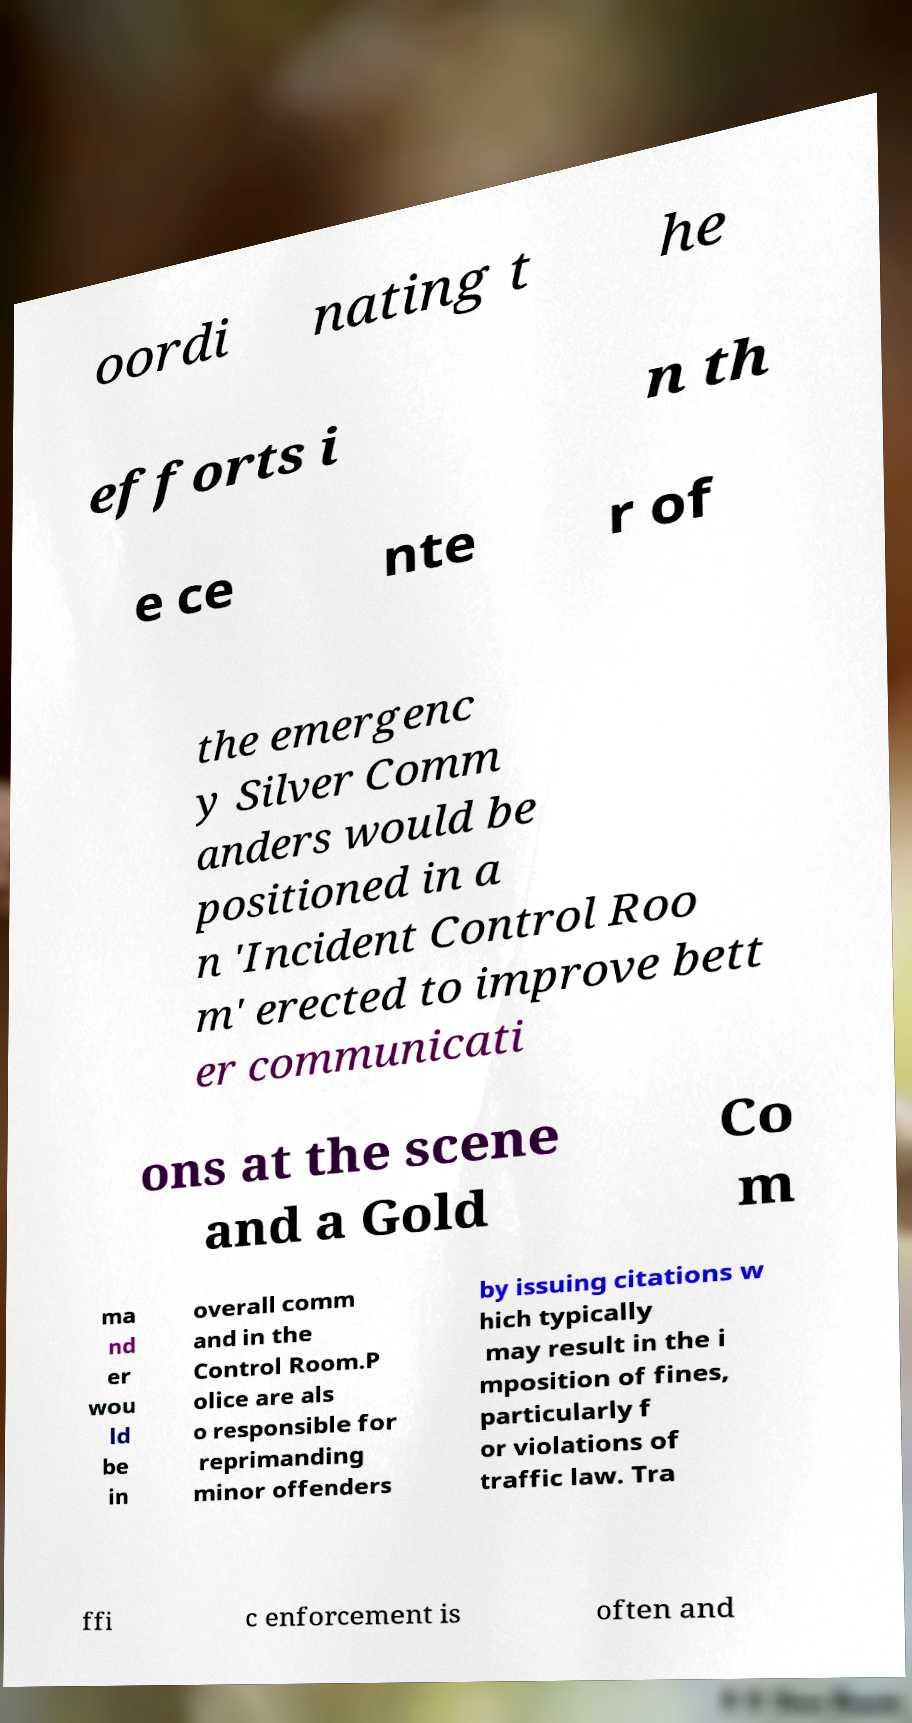Can you accurately transcribe the text from the provided image for me? oordi nating t he efforts i n th e ce nte r of the emergenc y Silver Comm anders would be positioned in a n 'Incident Control Roo m' erected to improve bett er communicati ons at the scene and a Gold Co m ma nd er wou ld be in overall comm and in the Control Room.P olice are als o responsible for reprimanding minor offenders by issuing citations w hich typically may result in the i mposition of fines, particularly f or violations of traffic law. Tra ffi c enforcement is often and 